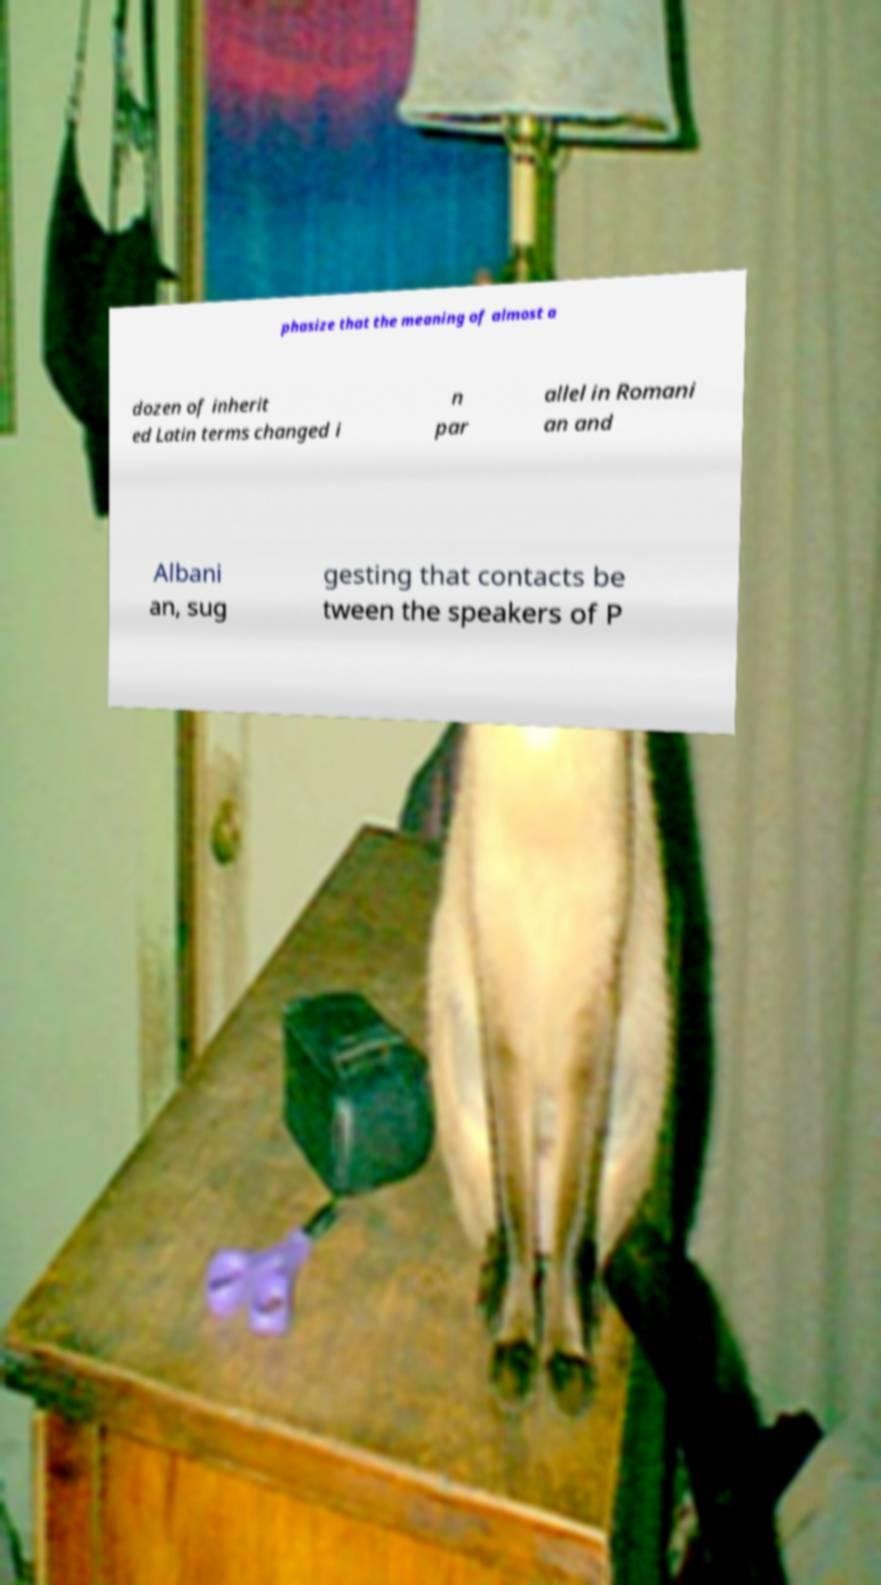Could you extract and type out the text from this image? phasize that the meaning of almost a dozen of inherit ed Latin terms changed i n par allel in Romani an and Albani an, sug gesting that contacts be tween the speakers of P 